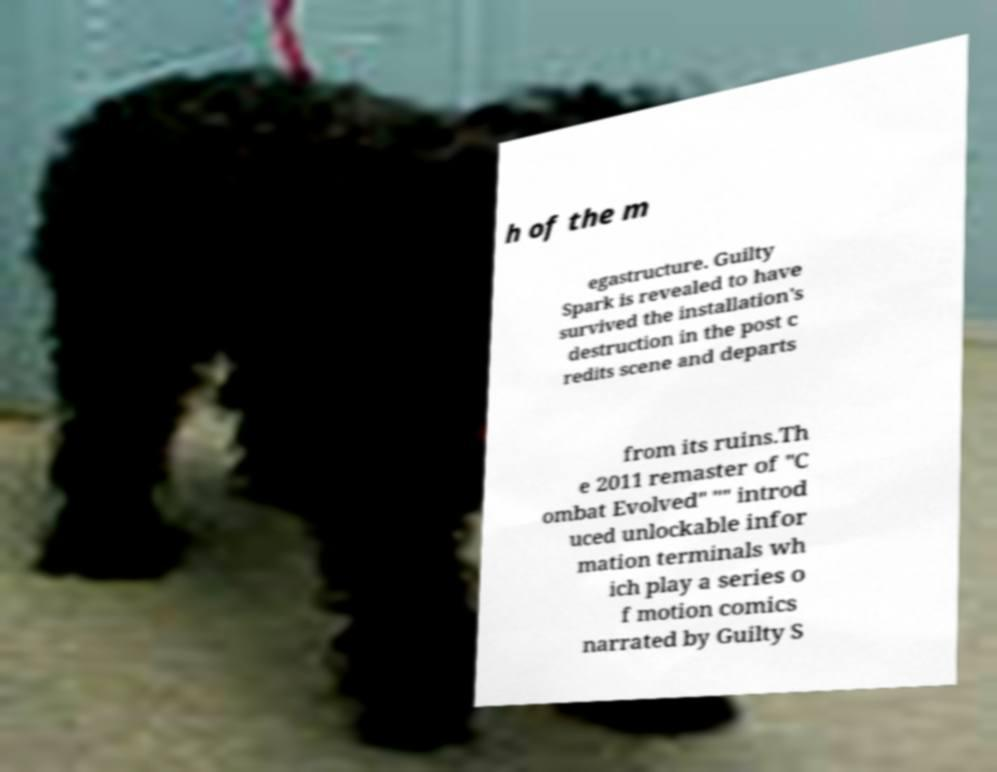There's text embedded in this image that I need extracted. Can you transcribe it verbatim? h of the m egastructure. Guilty Spark is revealed to have survived the installation's destruction in the post c redits scene and departs from its ruins.Th e 2011 remaster of "C ombat Evolved" "" introd uced unlockable infor mation terminals wh ich play a series o f motion comics narrated by Guilty S 